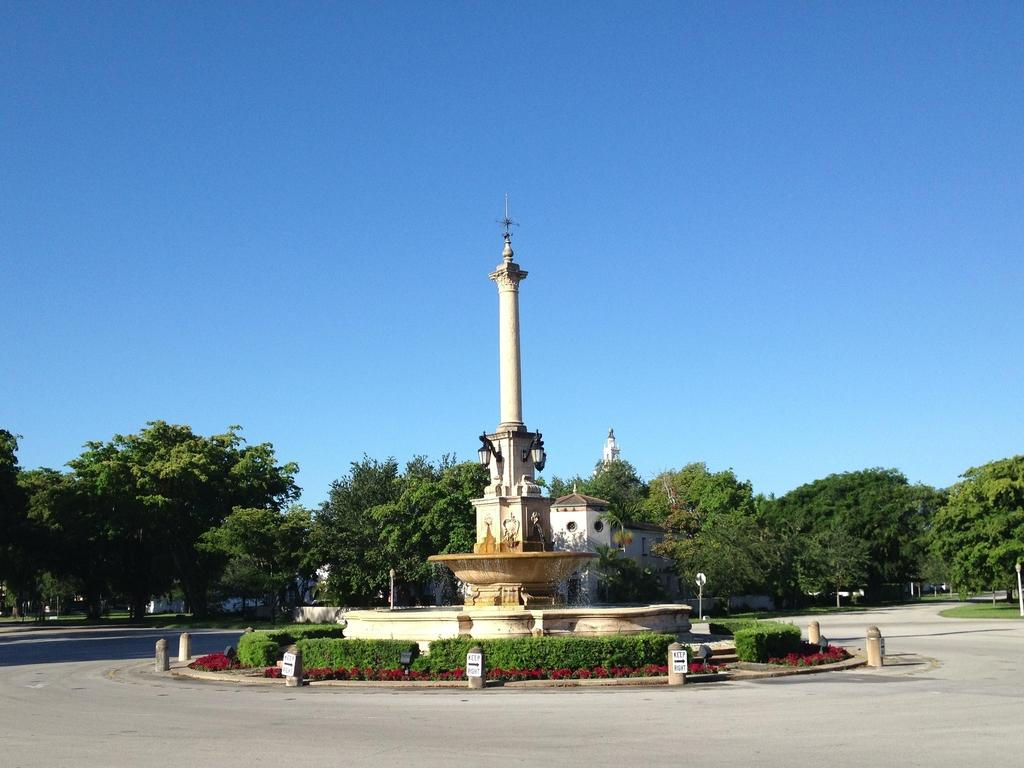What is the main feature in the image? There is a fountain in the image. What is located near the fountain? There are small plants around the fountain. What can be seen in the background of the image? There are trees in the background of the image. What is at the bottom of the image? There is a road at the bottom of the image. What is visible at the top of the image? The sky is visible at the top of the image. What type of crime is being committed near the fountain in the image? There is no crime being committed in the image; it features a fountain with small plants around it. What force is responsible for the fountain's water flow in the image? The image does not provide information about the force responsible for the fountain's water flow. 